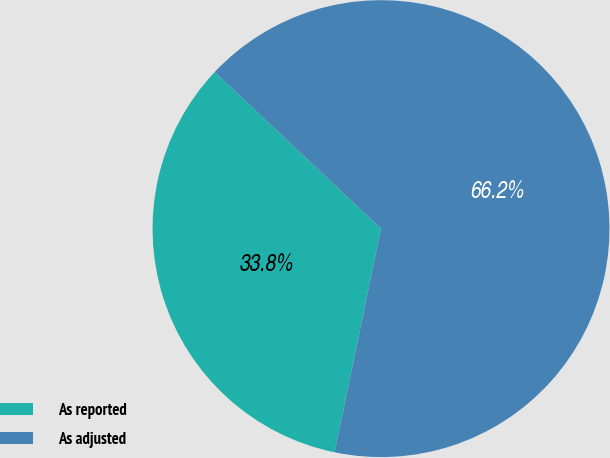Convert chart. <chart><loc_0><loc_0><loc_500><loc_500><pie_chart><fcel>As reported<fcel>As adjusted<nl><fcel>33.76%<fcel>66.24%<nl></chart> 